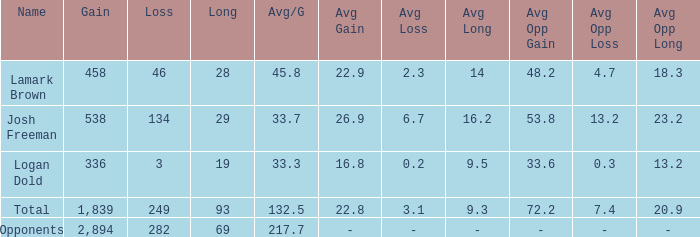Which avg/g has the name josh freeman and a loss less than 134? None. 